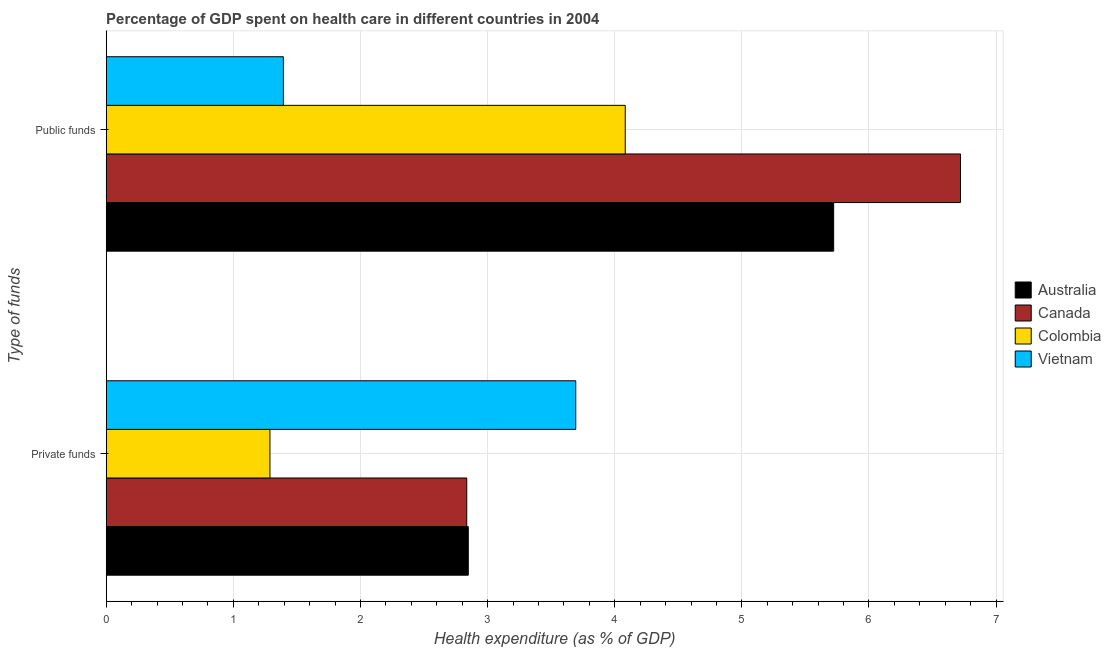How many different coloured bars are there?
Offer a terse response. 4. How many groups of bars are there?
Provide a short and direct response. 2. Are the number of bars per tick equal to the number of legend labels?
Offer a terse response. Yes. How many bars are there on the 2nd tick from the bottom?
Provide a short and direct response. 4. What is the label of the 2nd group of bars from the top?
Make the answer very short. Private funds. What is the amount of public funds spent in healthcare in Colombia?
Give a very brief answer. 4.08. Across all countries, what is the maximum amount of public funds spent in healthcare?
Offer a terse response. 6.72. Across all countries, what is the minimum amount of public funds spent in healthcare?
Make the answer very short. 1.39. In which country was the amount of public funds spent in healthcare minimum?
Your answer should be compact. Vietnam. What is the total amount of private funds spent in healthcare in the graph?
Offer a very short reply. 10.67. What is the difference between the amount of private funds spent in healthcare in Colombia and that in Canada?
Your answer should be very brief. -1.55. What is the difference between the amount of public funds spent in healthcare in Canada and the amount of private funds spent in healthcare in Colombia?
Offer a terse response. 5.43. What is the average amount of public funds spent in healthcare per country?
Provide a short and direct response. 4.48. What is the difference between the amount of public funds spent in healthcare and amount of private funds spent in healthcare in Australia?
Offer a very short reply. 2.87. What is the ratio of the amount of public funds spent in healthcare in Vietnam to that in Canada?
Offer a very short reply. 0.21. Is the amount of public funds spent in healthcare in Vietnam less than that in Australia?
Ensure brevity in your answer.  Yes. What does the 3rd bar from the bottom in Public funds represents?
Ensure brevity in your answer.  Colombia. How many bars are there?
Provide a short and direct response. 8. How many countries are there in the graph?
Keep it short and to the point. 4. What is the difference between two consecutive major ticks on the X-axis?
Provide a short and direct response. 1. Are the values on the major ticks of X-axis written in scientific E-notation?
Offer a terse response. No. Does the graph contain any zero values?
Offer a terse response. No. Where does the legend appear in the graph?
Make the answer very short. Center right. How many legend labels are there?
Keep it short and to the point. 4. What is the title of the graph?
Your response must be concise. Percentage of GDP spent on health care in different countries in 2004. Does "Croatia" appear as one of the legend labels in the graph?
Offer a terse response. No. What is the label or title of the X-axis?
Your response must be concise. Health expenditure (as % of GDP). What is the label or title of the Y-axis?
Keep it short and to the point. Type of funds. What is the Health expenditure (as % of GDP) in Australia in Private funds?
Your answer should be compact. 2.85. What is the Health expenditure (as % of GDP) in Canada in Private funds?
Offer a terse response. 2.84. What is the Health expenditure (as % of GDP) in Colombia in Private funds?
Provide a short and direct response. 1.29. What is the Health expenditure (as % of GDP) in Vietnam in Private funds?
Provide a succinct answer. 3.69. What is the Health expenditure (as % of GDP) in Australia in Public funds?
Keep it short and to the point. 5.72. What is the Health expenditure (as % of GDP) in Canada in Public funds?
Keep it short and to the point. 6.72. What is the Health expenditure (as % of GDP) in Colombia in Public funds?
Your answer should be compact. 4.08. What is the Health expenditure (as % of GDP) in Vietnam in Public funds?
Ensure brevity in your answer.  1.39. Across all Type of funds, what is the maximum Health expenditure (as % of GDP) in Australia?
Offer a very short reply. 5.72. Across all Type of funds, what is the maximum Health expenditure (as % of GDP) in Canada?
Give a very brief answer. 6.72. Across all Type of funds, what is the maximum Health expenditure (as % of GDP) of Colombia?
Keep it short and to the point. 4.08. Across all Type of funds, what is the maximum Health expenditure (as % of GDP) of Vietnam?
Your answer should be very brief. 3.69. Across all Type of funds, what is the minimum Health expenditure (as % of GDP) of Australia?
Your answer should be compact. 2.85. Across all Type of funds, what is the minimum Health expenditure (as % of GDP) in Canada?
Your answer should be very brief. 2.84. Across all Type of funds, what is the minimum Health expenditure (as % of GDP) of Colombia?
Your answer should be compact. 1.29. Across all Type of funds, what is the minimum Health expenditure (as % of GDP) in Vietnam?
Your response must be concise. 1.39. What is the total Health expenditure (as % of GDP) of Australia in the graph?
Make the answer very short. 8.57. What is the total Health expenditure (as % of GDP) of Canada in the graph?
Make the answer very short. 9.56. What is the total Health expenditure (as % of GDP) of Colombia in the graph?
Give a very brief answer. 5.37. What is the total Health expenditure (as % of GDP) in Vietnam in the graph?
Offer a terse response. 5.09. What is the difference between the Health expenditure (as % of GDP) in Australia in Private funds and that in Public funds?
Your answer should be compact. -2.87. What is the difference between the Health expenditure (as % of GDP) of Canada in Private funds and that in Public funds?
Give a very brief answer. -3.88. What is the difference between the Health expenditure (as % of GDP) in Colombia in Private funds and that in Public funds?
Keep it short and to the point. -2.79. What is the difference between the Health expenditure (as % of GDP) in Vietnam in Private funds and that in Public funds?
Ensure brevity in your answer.  2.3. What is the difference between the Health expenditure (as % of GDP) in Australia in Private funds and the Health expenditure (as % of GDP) in Canada in Public funds?
Your answer should be compact. -3.87. What is the difference between the Health expenditure (as % of GDP) in Australia in Private funds and the Health expenditure (as % of GDP) in Colombia in Public funds?
Provide a short and direct response. -1.23. What is the difference between the Health expenditure (as % of GDP) in Australia in Private funds and the Health expenditure (as % of GDP) in Vietnam in Public funds?
Give a very brief answer. 1.45. What is the difference between the Health expenditure (as % of GDP) in Canada in Private funds and the Health expenditure (as % of GDP) in Colombia in Public funds?
Give a very brief answer. -1.25. What is the difference between the Health expenditure (as % of GDP) in Canada in Private funds and the Health expenditure (as % of GDP) in Vietnam in Public funds?
Provide a succinct answer. 1.44. What is the difference between the Health expenditure (as % of GDP) of Colombia in Private funds and the Health expenditure (as % of GDP) of Vietnam in Public funds?
Provide a short and direct response. -0.11. What is the average Health expenditure (as % of GDP) in Australia per Type of funds?
Your answer should be very brief. 4.29. What is the average Health expenditure (as % of GDP) of Canada per Type of funds?
Your response must be concise. 4.78. What is the average Health expenditure (as % of GDP) of Colombia per Type of funds?
Make the answer very short. 2.69. What is the average Health expenditure (as % of GDP) of Vietnam per Type of funds?
Provide a succinct answer. 2.54. What is the difference between the Health expenditure (as % of GDP) of Australia and Health expenditure (as % of GDP) of Canada in Private funds?
Keep it short and to the point. 0.01. What is the difference between the Health expenditure (as % of GDP) in Australia and Health expenditure (as % of GDP) in Colombia in Private funds?
Ensure brevity in your answer.  1.56. What is the difference between the Health expenditure (as % of GDP) of Australia and Health expenditure (as % of GDP) of Vietnam in Private funds?
Give a very brief answer. -0.85. What is the difference between the Health expenditure (as % of GDP) in Canada and Health expenditure (as % of GDP) in Colombia in Private funds?
Your response must be concise. 1.55. What is the difference between the Health expenditure (as % of GDP) of Canada and Health expenditure (as % of GDP) of Vietnam in Private funds?
Ensure brevity in your answer.  -0.86. What is the difference between the Health expenditure (as % of GDP) of Colombia and Health expenditure (as % of GDP) of Vietnam in Private funds?
Your response must be concise. -2.41. What is the difference between the Health expenditure (as % of GDP) in Australia and Health expenditure (as % of GDP) in Canada in Public funds?
Give a very brief answer. -1. What is the difference between the Health expenditure (as % of GDP) in Australia and Health expenditure (as % of GDP) in Colombia in Public funds?
Provide a short and direct response. 1.64. What is the difference between the Health expenditure (as % of GDP) in Australia and Health expenditure (as % of GDP) in Vietnam in Public funds?
Offer a terse response. 4.33. What is the difference between the Health expenditure (as % of GDP) of Canada and Health expenditure (as % of GDP) of Colombia in Public funds?
Offer a very short reply. 2.64. What is the difference between the Health expenditure (as % of GDP) of Canada and Health expenditure (as % of GDP) of Vietnam in Public funds?
Give a very brief answer. 5.33. What is the difference between the Health expenditure (as % of GDP) of Colombia and Health expenditure (as % of GDP) of Vietnam in Public funds?
Provide a short and direct response. 2.69. What is the ratio of the Health expenditure (as % of GDP) of Australia in Private funds to that in Public funds?
Make the answer very short. 0.5. What is the ratio of the Health expenditure (as % of GDP) of Canada in Private funds to that in Public funds?
Ensure brevity in your answer.  0.42. What is the ratio of the Health expenditure (as % of GDP) in Colombia in Private funds to that in Public funds?
Your response must be concise. 0.32. What is the ratio of the Health expenditure (as % of GDP) in Vietnam in Private funds to that in Public funds?
Keep it short and to the point. 2.65. What is the difference between the highest and the second highest Health expenditure (as % of GDP) of Australia?
Your response must be concise. 2.87. What is the difference between the highest and the second highest Health expenditure (as % of GDP) of Canada?
Make the answer very short. 3.88. What is the difference between the highest and the second highest Health expenditure (as % of GDP) of Colombia?
Give a very brief answer. 2.79. What is the difference between the highest and the second highest Health expenditure (as % of GDP) in Vietnam?
Offer a terse response. 2.3. What is the difference between the highest and the lowest Health expenditure (as % of GDP) of Australia?
Ensure brevity in your answer.  2.87. What is the difference between the highest and the lowest Health expenditure (as % of GDP) in Canada?
Make the answer very short. 3.88. What is the difference between the highest and the lowest Health expenditure (as % of GDP) of Colombia?
Offer a terse response. 2.79. What is the difference between the highest and the lowest Health expenditure (as % of GDP) of Vietnam?
Provide a succinct answer. 2.3. 